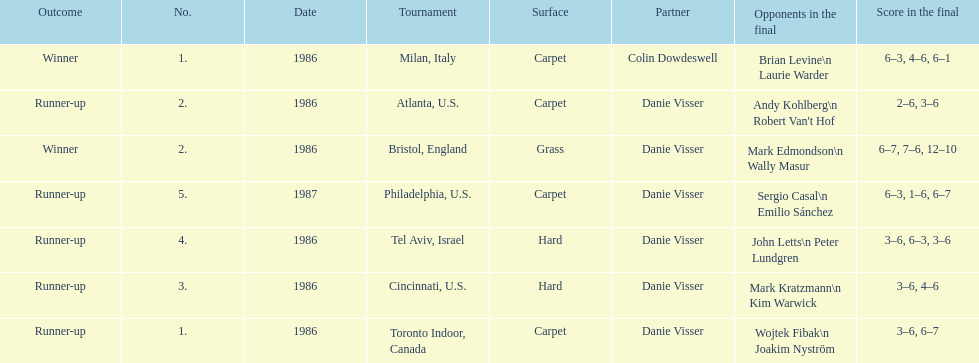What's the total of grass and hard surfaces listed? 3. 